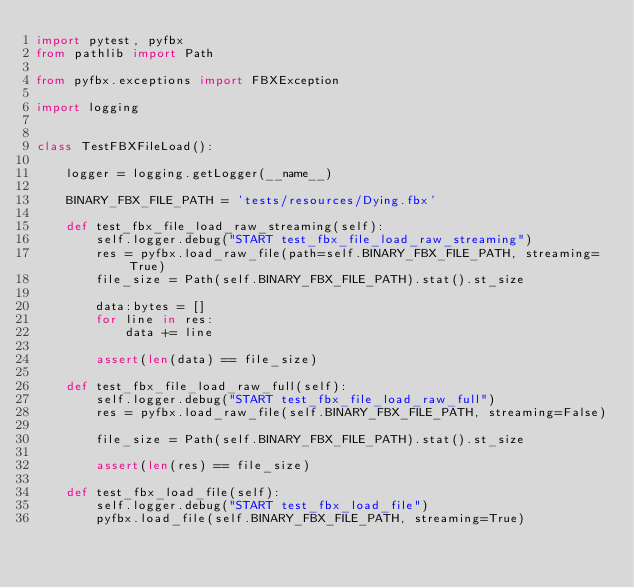Convert code to text. <code><loc_0><loc_0><loc_500><loc_500><_Python_>import pytest, pyfbx
from pathlib import Path

from pyfbx.exceptions import FBXException

import logging


class TestFBXFileLoad():

    logger = logging.getLogger(__name__)

    BINARY_FBX_FILE_PATH = 'tests/resources/Dying.fbx'

    def test_fbx_file_load_raw_streaming(self):
        self.logger.debug("START test_fbx_file_load_raw_streaming")
        res = pyfbx.load_raw_file(path=self.BINARY_FBX_FILE_PATH, streaming=True)
        file_size = Path(self.BINARY_FBX_FILE_PATH).stat().st_size

        data:bytes = []
        for line in res:
            data += line

        assert(len(data) == file_size)

    def test_fbx_file_load_raw_full(self):
        self.logger.debug("START test_fbx_file_load_raw_full")
        res = pyfbx.load_raw_file(self.BINARY_FBX_FILE_PATH, streaming=False)

        file_size = Path(self.BINARY_FBX_FILE_PATH).stat().st_size

        assert(len(res) == file_size)

    def test_fbx_load_file(self):
        self.logger.debug("START test_fbx_load_file")
        pyfbx.load_file(self.BINARY_FBX_FILE_PATH, streaming=True)</code> 